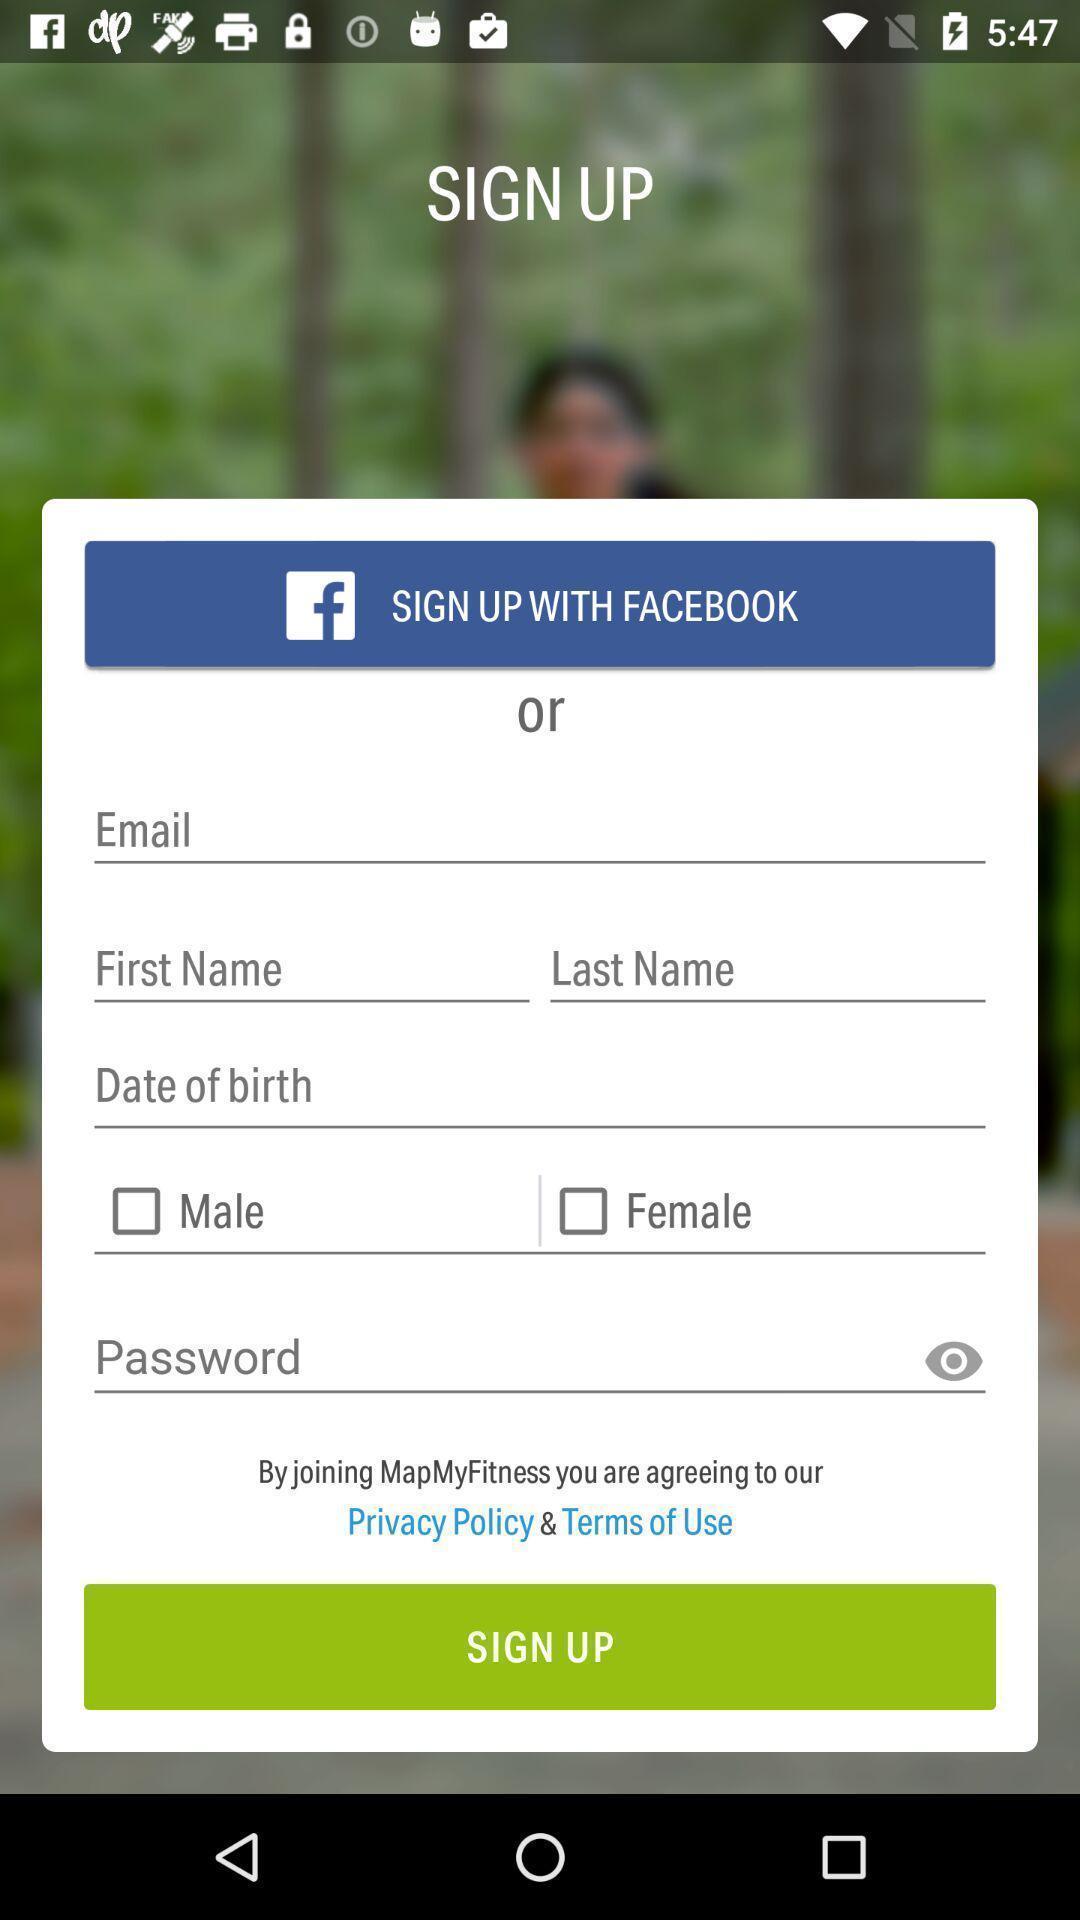Describe the key features of this screenshot. Sign up page of the app. 